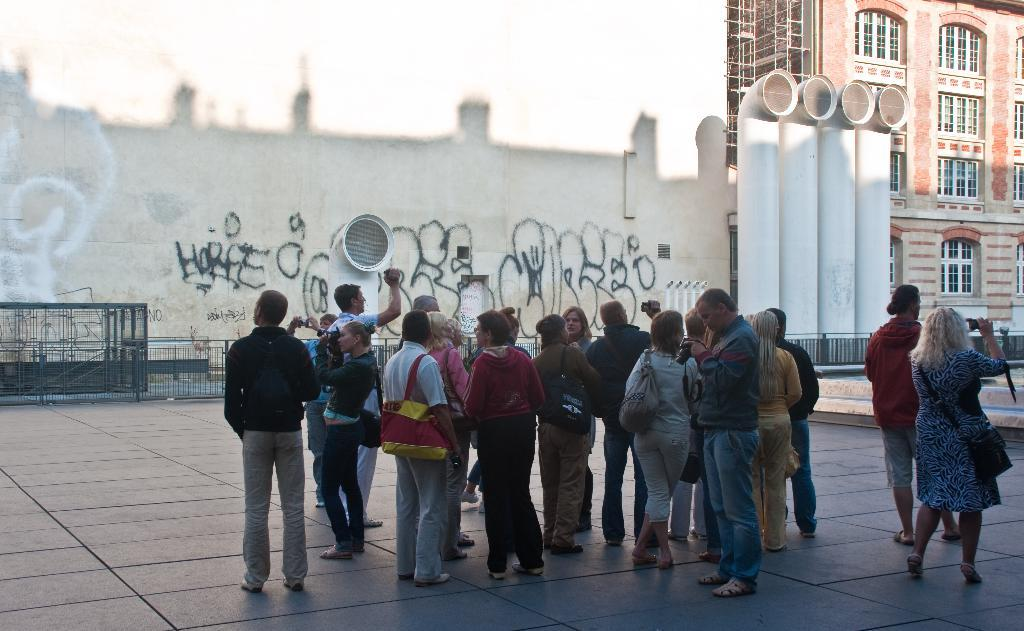How many people are in the group visible in the image? There is a group of people standing in the image, but the exact number cannot be determined from the provided facts. What type of structure can be seen in the image? There is a building in the image. What architectural feature is present in the image? There are iron grilles in the image. What is written or drawn on the wall in the image? There are scribblings on the wall in the image. What objects resemble pipes in the image? There are objects that look like pipes in the image. What type of comb is being used by the cattle in the image? There are no cattle or combs present in the image. 